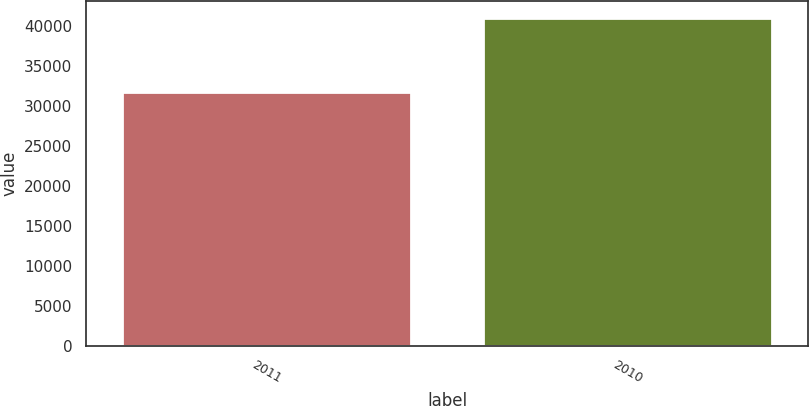Convert chart. <chart><loc_0><loc_0><loc_500><loc_500><bar_chart><fcel>2011<fcel>2010<nl><fcel>31754<fcel>40983<nl></chart> 